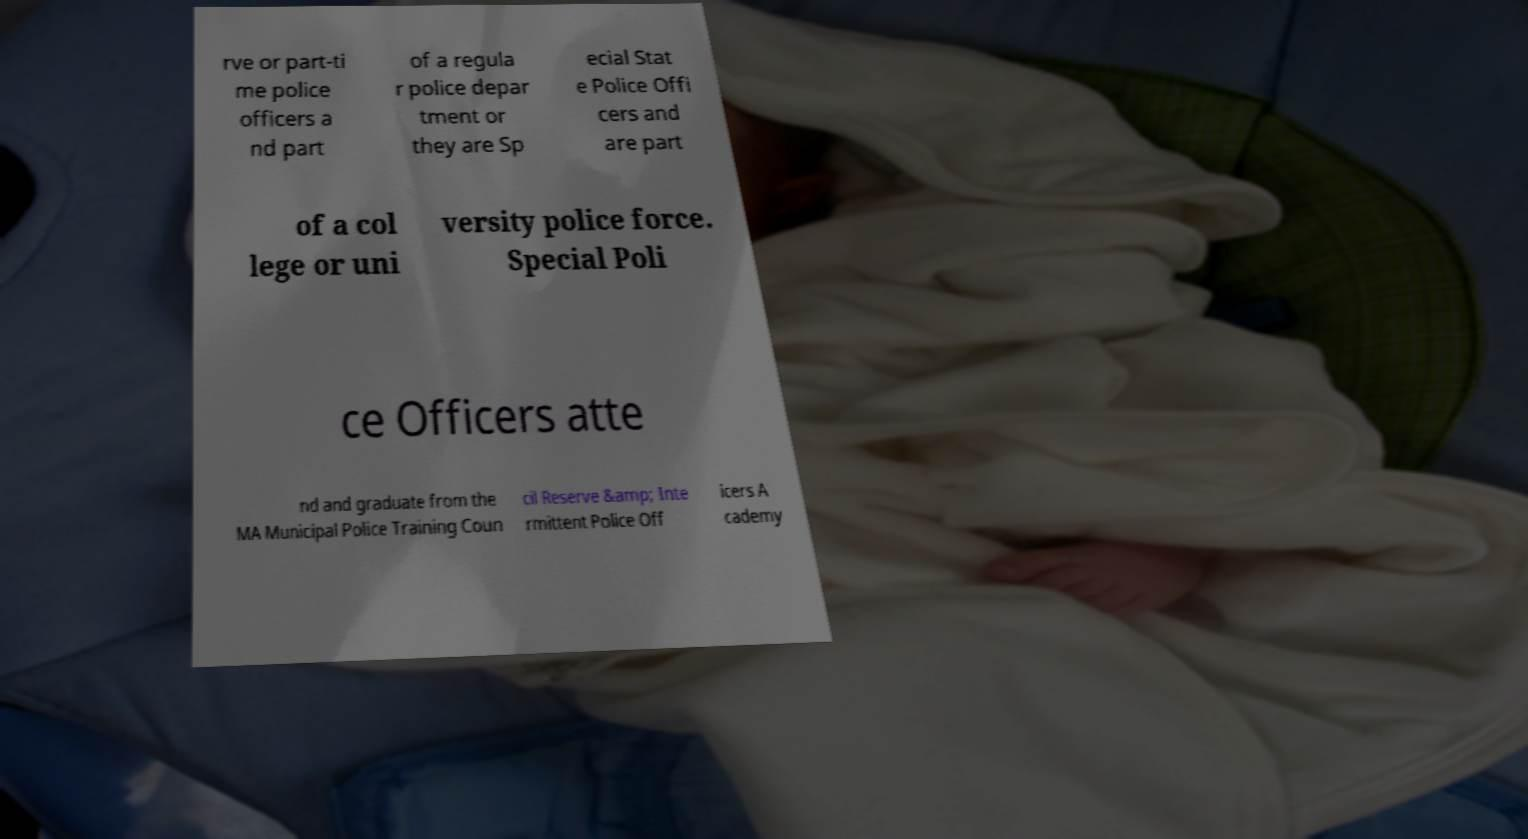What messages or text are displayed in this image? I need them in a readable, typed format. rve or part-ti me police officers a nd part of a regula r police depar tment or they are Sp ecial Stat e Police Offi cers and are part of a col lege or uni versity police force. Special Poli ce Officers atte nd and graduate from the MA Municipal Police Training Coun cil Reserve &amp; Inte rmittent Police Off icers A cademy 